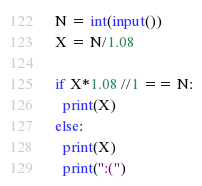<code> <loc_0><loc_0><loc_500><loc_500><_Python_>N = int(input())
X = N/1.08

if X*1.08 //1 == N:
  print(X)
else:
  print(X)
  print(":(")
</code> 